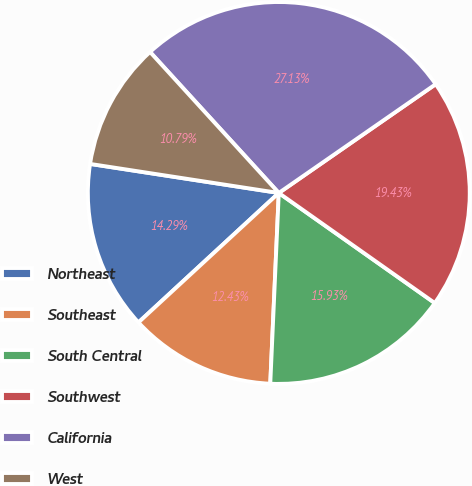Convert chart to OTSL. <chart><loc_0><loc_0><loc_500><loc_500><pie_chart><fcel>Northeast<fcel>Southeast<fcel>South Central<fcel>Southwest<fcel>California<fcel>West<nl><fcel>14.29%<fcel>12.43%<fcel>15.93%<fcel>19.43%<fcel>27.13%<fcel>10.79%<nl></chart> 